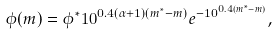Convert formula to latex. <formula><loc_0><loc_0><loc_500><loc_500>\phi ( m ) = \phi ^ { * } 1 0 ^ { 0 . 4 ( \alpha + 1 ) ( m ^ { * } - m ) } e ^ { - 1 0 ^ { 0 . 4 ( m ^ { * } - m ) } } ,</formula> 